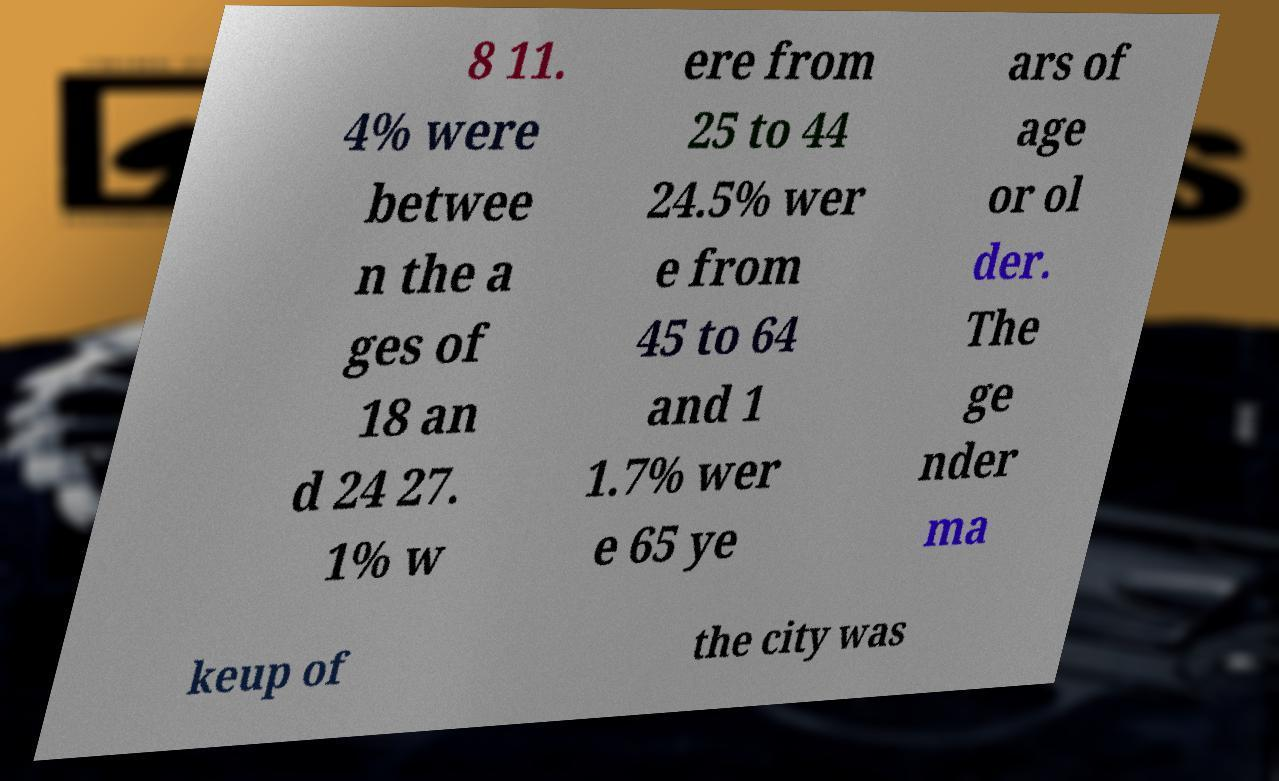For documentation purposes, I need the text within this image transcribed. Could you provide that? 8 11. 4% were betwee n the a ges of 18 an d 24 27. 1% w ere from 25 to 44 24.5% wer e from 45 to 64 and 1 1.7% wer e 65 ye ars of age or ol der. The ge nder ma keup of the city was 